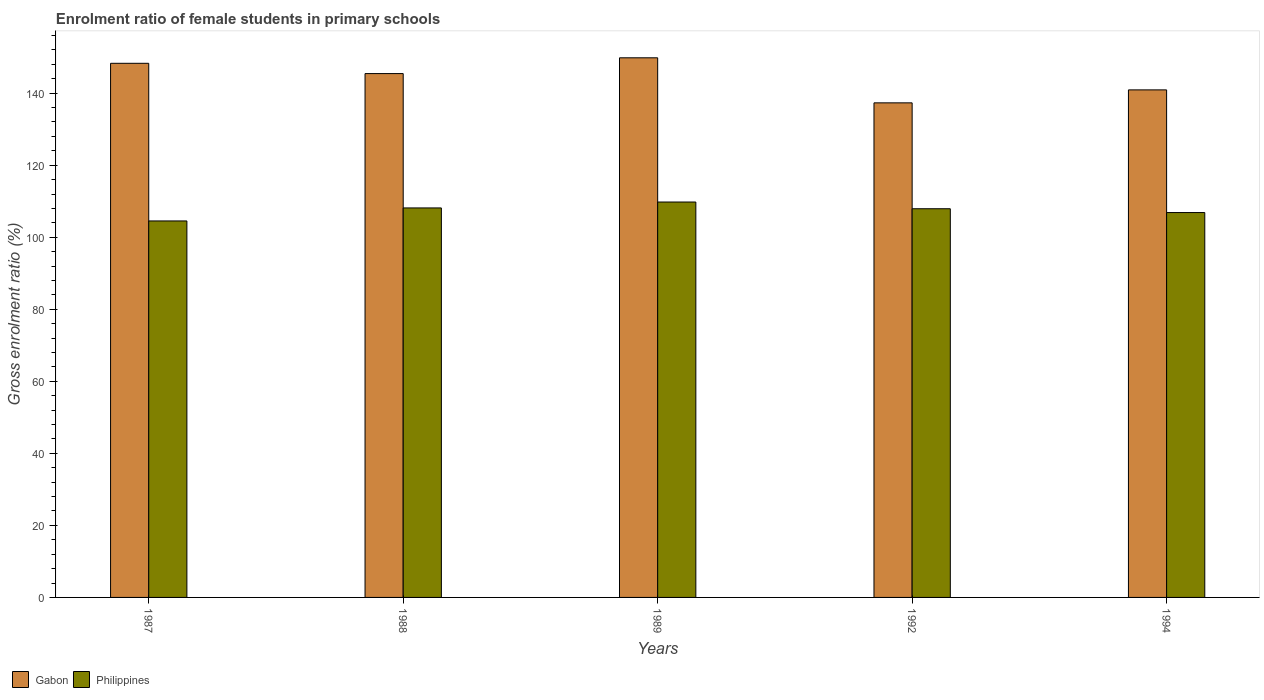How many different coloured bars are there?
Give a very brief answer. 2. Are the number of bars per tick equal to the number of legend labels?
Provide a short and direct response. Yes. How many bars are there on the 1st tick from the left?
Offer a very short reply. 2. In how many cases, is the number of bars for a given year not equal to the number of legend labels?
Offer a terse response. 0. What is the enrolment ratio of female students in primary schools in Gabon in 1987?
Offer a terse response. 148.29. Across all years, what is the maximum enrolment ratio of female students in primary schools in Philippines?
Offer a very short reply. 109.78. Across all years, what is the minimum enrolment ratio of female students in primary schools in Gabon?
Make the answer very short. 137.31. In which year was the enrolment ratio of female students in primary schools in Philippines minimum?
Keep it short and to the point. 1987. What is the total enrolment ratio of female students in primary schools in Philippines in the graph?
Keep it short and to the point. 537.2. What is the difference between the enrolment ratio of female students in primary schools in Philippines in 1989 and that in 1994?
Ensure brevity in your answer.  2.93. What is the difference between the enrolment ratio of female students in primary schools in Philippines in 1992 and the enrolment ratio of female students in primary schools in Gabon in 1989?
Provide a short and direct response. -41.91. What is the average enrolment ratio of female students in primary schools in Philippines per year?
Offer a very short reply. 107.44. In the year 1992, what is the difference between the enrolment ratio of female students in primary schools in Gabon and enrolment ratio of female students in primary schools in Philippines?
Ensure brevity in your answer.  29.4. In how many years, is the enrolment ratio of female students in primary schools in Philippines greater than 48 %?
Make the answer very short. 5. What is the ratio of the enrolment ratio of female students in primary schools in Philippines in 1989 to that in 1992?
Ensure brevity in your answer.  1.02. Is the enrolment ratio of female students in primary schools in Philippines in 1987 less than that in 1989?
Offer a terse response. Yes. What is the difference between the highest and the second highest enrolment ratio of female students in primary schools in Gabon?
Provide a succinct answer. 1.53. What is the difference between the highest and the lowest enrolment ratio of female students in primary schools in Philippines?
Offer a very short reply. 5.25. What does the 1st bar from the left in 1994 represents?
Offer a terse response. Gabon. How many years are there in the graph?
Ensure brevity in your answer.  5. Does the graph contain any zero values?
Ensure brevity in your answer.  No. Does the graph contain grids?
Provide a succinct answer. No. Where does the legend appear in the graph?
Make the answer very short. Bottom left. How are the legend labels stacked?
Make the answer very short. Horizontal. What is the title of the graph?
Your response must be concise. Enrolment ratio of female students in primary schools. What is the label or title of the X-axis?
Your answer should be compact. Years. What is the Gross enrolment ratio (%) in Gabon in 1987?
Offer a terse response. 148.29. What is the Gross enrolment ratio (%) in Philippines in 1987?
Your response must be concise. 104.52. What is the Gross enrolment ratio (%) of Gabon in 1988?
Keep it short and to the point. 145.44. What is the Gross enrolment ratio (%) of Philippines in 1988?
Provide a short and direct response. 108.14. What is the Gross enrolment ratio (%) of Gabon in 1989?
Provide a short and direct response. 149.81. What is the Gross enrolment ratio (%) of Philippines in 1989?
Your response must be concise. 109.78. What is the Gross enrolment ratio (%) in Gabon in 1992?
Ensure brevity in your answer.  137.31. What is the Gross enrolment ratio (%) in Philippines in 1992?
Make the answer very short. 107.91. What is the Gross enrolment ratio (%) in Gabon in 1994?
Offer a very short reply. 140.91. What is the Gross enrolment ratio (%) in Philippines in 1994?
Your answer should be very brief. 106.85. Across all years, what is the maximum Gross enrolment ratio (%) in Gabon?
Give a very brief answer. 149.81. Across all years, what is the maximum Gross enrolment ratio (%) in Philippines?
Your response must be concise. 109.78. Across all years, what is the minimum Gross enrolment ratio (%) in Gabon?
Ensure brevity in your answer.  137.31. Across all years, what is the minimum Gross enrolment ratio (%) of Philippines?
Keep it short and to the point. 104.52. What is the total Gross enrolment ratio (%) in Gabon in the graph?
Offer a very short reply. 721.76. What is the total Gross enrolment ratio (%) of Philippines in the graph?
Make the answer very short. 537.2. What is the difference between the Gross enrolment ratio (%) in Gabon in 1987 and that in 1988?
Make the answer very short. 2.85. What is the difference between the Gross enrolment ratio (%) in Philippines in 1987 and that in 1988?
Your answer should be very brief. -3.61. What is the difference between the Gross enrolment ratio (%) in Gabon in 1987 and that in 1989?
Your response must be concise. -1.53. What is the difference between the Gross enrolment ratio (%) in Philippines in 1987 and that in 1989?
Your response must be concise. -5.25. What is the difference between the Gross enrolment ratio (%) in Gabon in 1987 and that in 1992?
Offer a terse response. 10.98. What is the difference between the Gross enrolment ratio (%) in Philippines in 1987 and that in 1992?
Make the answer very short. -3.39. What is the difference between the Gross enrolment ratio (%) of Gabon in 1987 and that in 1994?
Your response must be concise. 7.38. What is the difference between the Gross enrolment ratio (%) of Philippines in 1987 and that in 1994?
Make the answer very short. -2.33. What is the difference between the Gross enrolment ratio (%) of Gabon in 1988 and that in 1989?
Make the answer very short. -4.38. What is the difference between the Gross enrolment ratio (%) in Philippines in 1988 and that in 1989?
Keep it short and to the point. -1.64. What is the difference between the Gross enrolment ratio (%) in Gabon in 1988 and that in 1992?
Your answer should be compact. 8.13. What is the difference between the Gross enrolment ratio (%) in Philippines in 1988 and that in 1992?
Offer a very short reply. 0.23. What is the difference between the Gross enrolment ratio (%) of Gabon in 1988 and that in 1994?
Make the answer very short. 4.52. What is the difference between the Gross enrolment ratio (%) of Philippines in 1988 and that in 1994?
Offer a terse response. 1.28. What is the difference between the Gross enrolment ratio (%) of Gabon in 1989 and that in 1992?
Offer a very short reply. 12.51. What is the difference between the Gross enrolment ratio (%) of Philippines in 1989 and that in 1992?
Make the answer very short. 1.87. What is the difference between the Gross enrolment ratio (%) of Gabon in 1989 and that in 1994?
Your answer should be compact. 8.9. What is the difference between the Gross enrolment ratio (%) in Philippines in 1989 and that in 1994?
Your answer should be very brief. 2.93. What is the difference between the Gross enrolment ratio (%) in Gabon in 1992 and that in 1994?
Provide a short and direct response. -3.6. What is the difference between the Gross enrolment ratio (%) in Philippines in 1992 and that in 1994?
Offer a very short reply. 1.06. What is the difference between the Gross enrolment ratio (%) in Gabon in 1987 and the Gross enrolment ratio (%) in Philippines in 1988?
Ensure brevity in your answer.  40.15. What is the difference between the Gross enrolment ratio (%) in Gabon in 1987 and the Gross enrolment ratio (%) in Philippines in 1989?
Make the answer very short. 38.51. What is the difference between the Gross enrolment ratio (%) in Gabon in 1987 and the Gross enrolment ratio (%) in Philippines in 1992?
Provide a succinct answer. 40.38. What is the difference between the Gross enrolment ratio (%) of Gabon in 1987 and the Gross enrolment ratio (%) of Philippines in 1994?
Offer a very short reply. 41.44. What is the difference between the Gross enrolment ratio (%) in Gabon in 1988 and the Gross enrolment ratio (%) in Philippines in 1989?
Keep it short and to the point. 35.66. What is the difference between the Gross enrolment ratio (%) of Gabon in 1988 and the Gross enrolment ratio (%) of Philippines in 1992?
Ensure brevity in your answer.  37.53. What is the difference between the Gross enrolment ratio (%) of Gabon in 1988 and the Gross enrolment ratio (%) of Philippines in 1994?
Offer a very short reply. 38.58. What is the difference between the Gross enrolment ratio (%) of Gabon in 1989 and the Gross enrolment ratio (%) of Philippines in 1992?
Ensure brevity in your answer.  41.91. What is the difference between the Gross enrolment ratio (%) in Gabon in 1989 and the Gross enrolment ratio (%) in Philippines in 1994?
Ensure brevity in your answer.  42.96. What is the difference between the Gross enrolment ratio (%) in Gabon in 1992 and the Gross enrolment ratio (%) in Philippines in 1994?
Offer a terse response. 30.46. What is the average Gross enrolment ratio (%) of Gabon per year?
Offer a terse response. 144.35. What is the average Gross enrolment ratio (%) in Philippines per year?
Ensure brevity in your answer.  107.44. In the year 1987, what is the difference between the Gross enrolment ratio (%) of Gabon and Gross enrolment ratio (%) of Philippines?
Your answer should be compact. 43.77. In the year 1988, what is the difference between the Gross enrolment ratio (%) of Gabon and Gross enrolment ratio (%) of Philippines?
Make the answer very short. 37.3. In the year 1989, what is the difference between the Gross enrolment ratio (%) of Gabon and Gross enrolment ratio (%) of Philippines?
Your response must be concise. 40.04. In the year 1992, what is the difference between the Gross enrolment ratio (%) in Gabon and Gross enrolment ratio (%) in Philippines?
Provide a succinct answer. 29.4. In the year 1994, what is the difference between the Gross enrolment ratio (%) in Gabon and Gross enrolment ratio (%) in Philippines?
Make the answer very short. 34.06. What is the ratio of the Gross enrolment ratio (%) of Gabon in 1987 to that in 1988?
Keep it short and to the point. 1.02. What is the ratio of the Gross enrolment ratio (%) in Philippines in 1987 to that in 1988?
Provide a short and direct response. 0.97. What is the ratio of the Gross enrolment ratio (%) of Philippines in 1987 to that in 1989?
Provide a short and direct response. 0.95. What is the ratio of the Gross enrolment ratio (%) of Gabon in 1987 to that in 1992?
Keep it short and to the point. 1.08. What is the ratio of the Gross enrolment ratio (%) of Philippines in 1987 to that in 1992?
Offer a terse response. 0.97. What is the ratio of the Gross enrolment ratio (%) of Gabon in 1987 to that in 1994?
Provide a short and direct response. 1.05. What is the ratio of the Gross enrolment ratio (%) in Philippines in 1987 to that in 1994?
Your answer should be very brief. 0.98. What is the ratio of the Gross enrolment ratio (%) in Gabon in 1988 to that in 1989?
Offer a very short reply. 0.97. What is the ratio of the Gross enrolment ratio (%) of Gabon in 1988 to that in 1992?
Your answer should be very brief. 1.06. What is the ratio of the Gross enrolment ratio (%) in Gabon in 1988 to that in 1994?
Make the answer very short. 1.03. What is the ratio of the Gross enrolment ratio (%) in Philippines in 1988 to that in 1994?
Offer a very short reply. 1.01. What is the ratio of the Gross enrolment ratio (%) in Gabon in 1989 to that in 1992?
Make the answer very short. 1.09. What is the ratio of the Gross enrolment ratio (%) in Philippines in 1989 to that in 1992?
Provide a succinct answer. 1.02. What is the ratio of the Gross enrolment ratio (%) in Gabon in 1989 to that in 1994?
Your answer should be very brief. 1.06. What is the ratio of the Gross enrolment ratio (%) of Philippines in 1989 to that in 1994?
Your answer should be compact. 1.03. What is the ratio of the Gross enrolment ratio (%) of Gabon in 1992 to that in 1994?
Provide a short and direct response. 0.97. What is the ratio of the Gross enrolment ratio (%) of Philippines in 1992 to that in 1994?
Offer a terse response. 1.01. What is the difference between the highest and the second highest Gross enrolment ratio (%) of Gabon?
Your response must be concise. 1.53. What is the difference between the highest and the second highest Gross enrolment ratio (%) of Philippines?
Keep it short and to the point. 1.64. What is the difference between the highest and the lowest Gross enrolment ratio (%) of Gabon?
Your answer should be compact. 12.51. What is the difference between the highest and the lowest Gross enrolment ratio (%) of Philippines?
Your response must be concise. 5.25. 